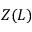Convert formula to latex. <formula><loc_0><loc_0><loc_500><loc_500>Z ( L )</formula> 